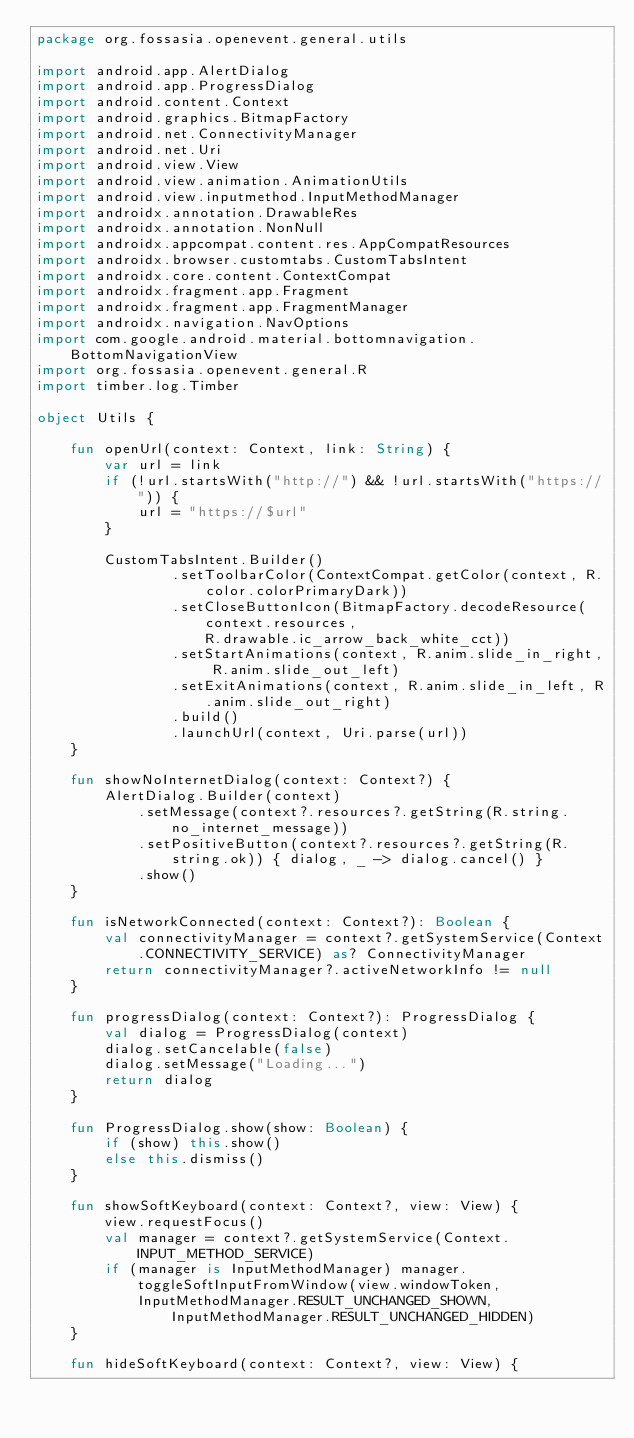Convert code to text. <code><loc_0><loc_0><loc_500><loc_500><_Kotlin_>package org.fossasia.openevent.general.utils

import android.app.AlertDialog
import android.app.ProgressDialog
import android.content.Context
import android.graphics.BitmapFactory
import android.net.ConnectivityManager
import android.net.Uri
import android.view.View
import android.view.animation.AnimationUtils
import android.view.inputmethod.InputMethodManager
import androidx.annotation.DrawableRes
import androidx.annotation.NonNull
import androidx.appcompat.content.res.AppCompatResources
import androidx.browser.customtabs.CustomTabsIntent
import androidx.core.content.ContextCompat
import androidx.fragment.app.Fragment
import androidx.fragment.app.FragmentManager
import androidx.navigation.NavOptions
import com.google.android.material.bottomnavigation.BottomNavigationView
import org.fossasia.openevent.general.R
import timber.log.Timber

object Utils {

    fun openUrl(context: Context, link: String) {
        var url = link
        if (!url.startsWith("http://") && !url.startsWith("https://")) {
            url = "https://$url"
        }

        CustomTabsIntent.Builder()
                .setToolbarColor(ContextCompat.getColor(context, R.color.colorPrimaryDark))
                .setCloseButtonIcon(BitmapFactory.decodeResource(context.resources,
                    R.drawable.ic_arrow_back_white_cct))
                .setStartAnimations(context, R.anim.slide_in_right, R.anim.slide_out_left)
                .setExitAnimations(context, R.anim.slide_in_left, R.anim.slide_out_right)
                .build()
                .launchUrl(context, Uri.parse(url))
    }

    fun showNoInternetDialog(context: Context?) {
        AlertDialog.Builder(context)
            .setMessage(context?.resources?.getString(R.string.no_internet_message))
            .setPositiveButton(context?.resources?.getString(R.string.ok)) { dialog, _ -> dialog.cancel() }
            .show()
    }

    fun isNetworkConnected(context: Context?): Boolean {
        val connectivityManager = context?.getSystemService(Context.CONNECTIVITY_SERVICE) as? ConnectivityManager
        return connectivityManager?.activeNetworkInfo != null
    }

    fun progressDialog(context: Context?): ProgressDialog {
        val dialog = ProgressDialog(context)
        dialog.setCancelable(false)
        dialog.setMessage("Loading...")
        return dialog
    }

    fun ProgressDialog.show(show: Boolean) {
        if (show) this.show()
        else this.dismiss()
    }

    fun showSoftKeyboard(context: Context?, view: View) {
        view.requestFocus()
        val manager = context?.getSystemService(Context.INPUT_METHOD_SERVICE)
        if (manager is InputMethodManager) manager.toggleSoftInputFromWindow(view.windowToken,
            InputMethodManager.RESULT_UNCHANGED_SHOWN, InputMethodManager.RESULT_UNCHANGED_HIDDEN)
    }

    fun hideSoftKeyboard(context: Context?, view: View) {</code> 